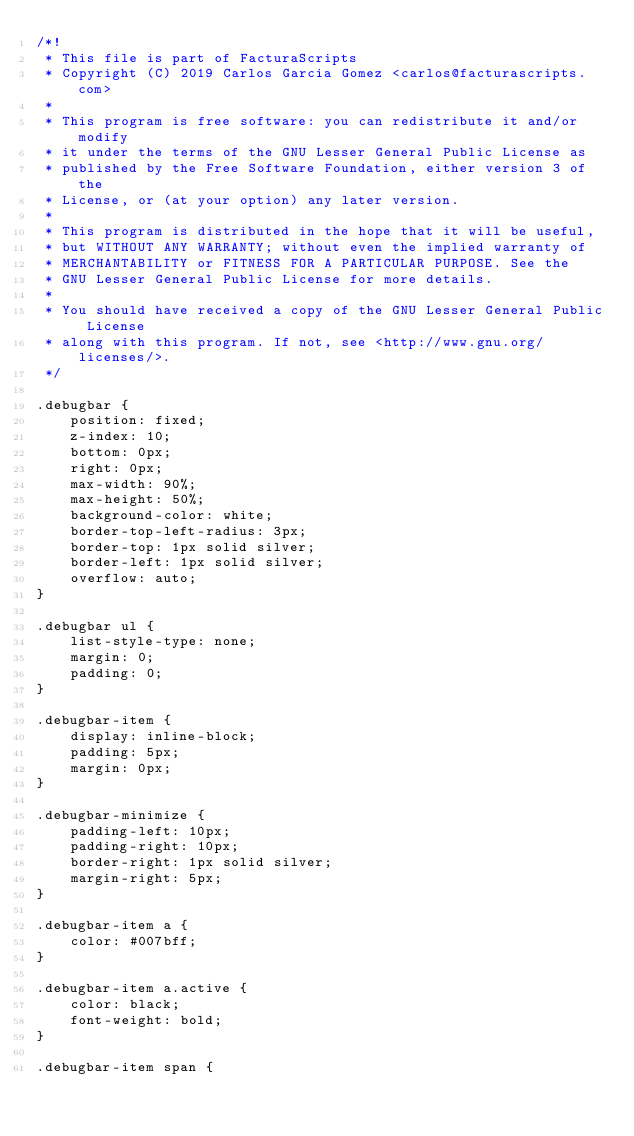Convert code to text. <code><loc_0><loc_0><loc_500><loc_500><_CSS_>/*!
 * This file is part of FacturaScripts
 * Copyright (C) 2019 Carlos Garcia Gomez <carlos@facturascripts.com>
 *
 * This program is free software: you can redistribute it and/or modify
 * it under the terms of the GNU Lesser General Public License as
 * published by the Free Software Foundation, either version 3 of the
 * License, or (at your option) any later version.
 *
 * This program is distributed in the hope that it will be useful,
 * but WITHOUT ANY WARRANTY; without even the implied warranty of
 * MERCHANTABILITY or FITNESS FOR A PARTICULAR PURPOSE. See the
 * GNU Lesser General Public License for more details.
 *
 * You should have received a copy of the GNU Lesser General Public License
 * along with this program. If not, see <http://www.gnu.org/licenses/>.
 */

.debugbar {
    position: fixed;
    z-index: 10;
    bottom: 0px;
    right: 0px;
    max-width: 90%;
    max-height: 50%;
    background-color: white;
    border-top-left-radius: 3px;
    border-top: 1px solid silver;
    border-left: 1px solid silver;
    overflow: auto;
}

.debugbar ul {
    list-style-type: none;
    margin: 0;
    padding: 0;
}

.debugbar-item {
    display: inline-block;
    padding: 5px;
    margin: 0px;
}

.debugbar-minimize {
    padding-left: 10px;
    padding-right: 10px;
    border-right: 1px solid silver;
    margin-right: 5px;
}

.debugbar-item a {
    color: #007bff;
}

.debugbar-item a.active {
    color: black;
    font-weight: bold;
}

.debugbar-item span {</code> 